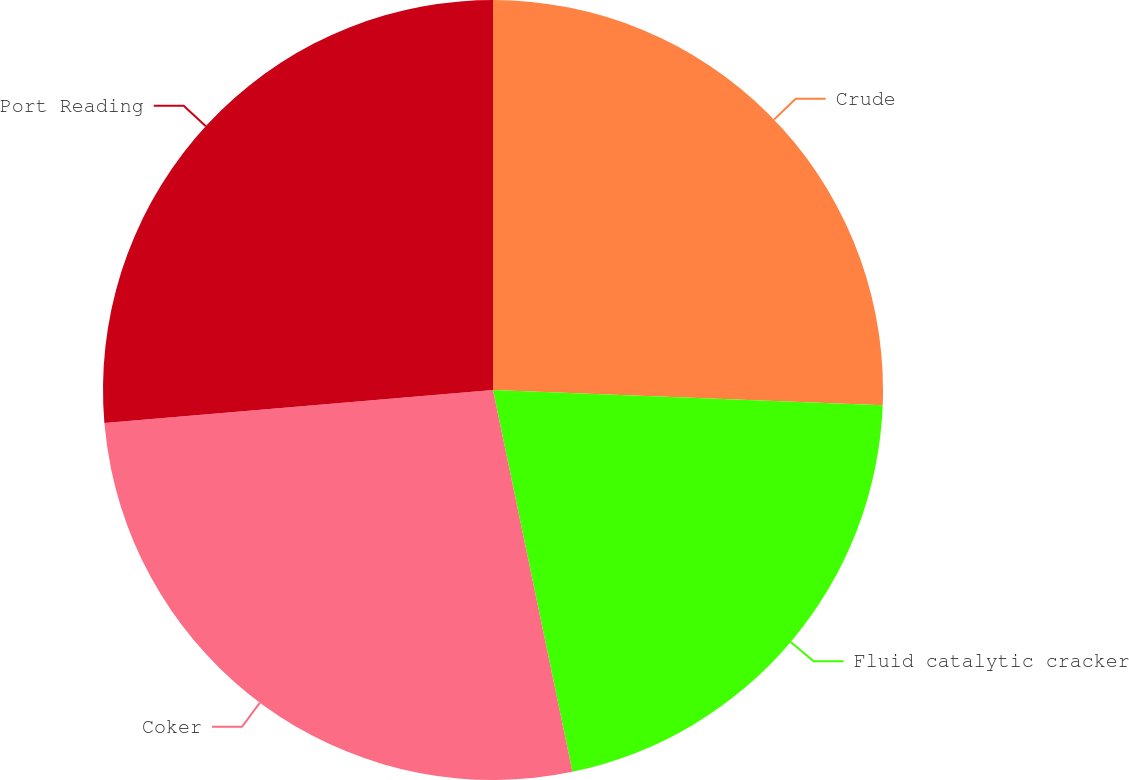Convert chart. <chart><loc_0><loc_0><loc_500><loc_500><pie_chart><fcel>Crude<fcel>Fluid catalytic cracker<fcel>Coker<fcel>Port Reading<nl><fcel>25.62%<fcel>21.12%<fcel>26.92%<fcel>26.35%<nl></chart> 